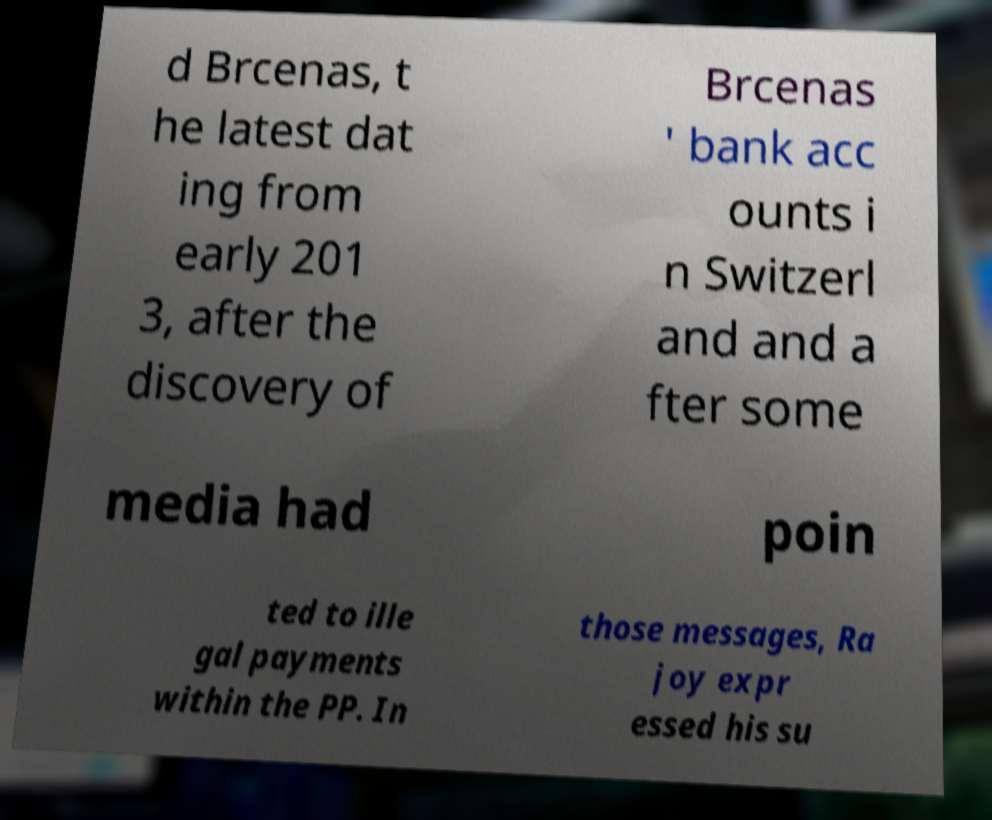I need the written content from this picture converted into text. Can you do that? d Brcenas, t he latest dat ing from early 201 3, after the discovery of Brcenas ' bank acc ounts i n Switzerl and and a fter some media had poin ted to ille gal payments within the PP. In those messages, Ra joy expr essed his su 